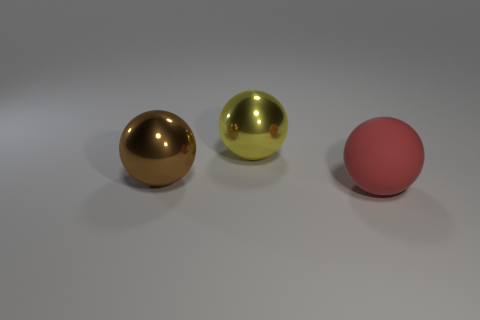Add 2 large red things. How many objects exist? 5 Subtract all large metal spheres. How many spheres are left? 1 Subtract 3 balls. How many balls are left? 0 Subtract all red spheres. Subtract all red blocks. How many spheres are left? 2 Subtract all small brown matte balls. Subtract all shiny things. How many objects are left? 1 Add 2 red matte balls. How many red matte balls are left? 3 Add 2 big brown objects. How many big brown objects exist? 3 Subtract all brown balls. How many balls are left? 2 Subtract 0 yellow blocks. How many objects are left? 3 